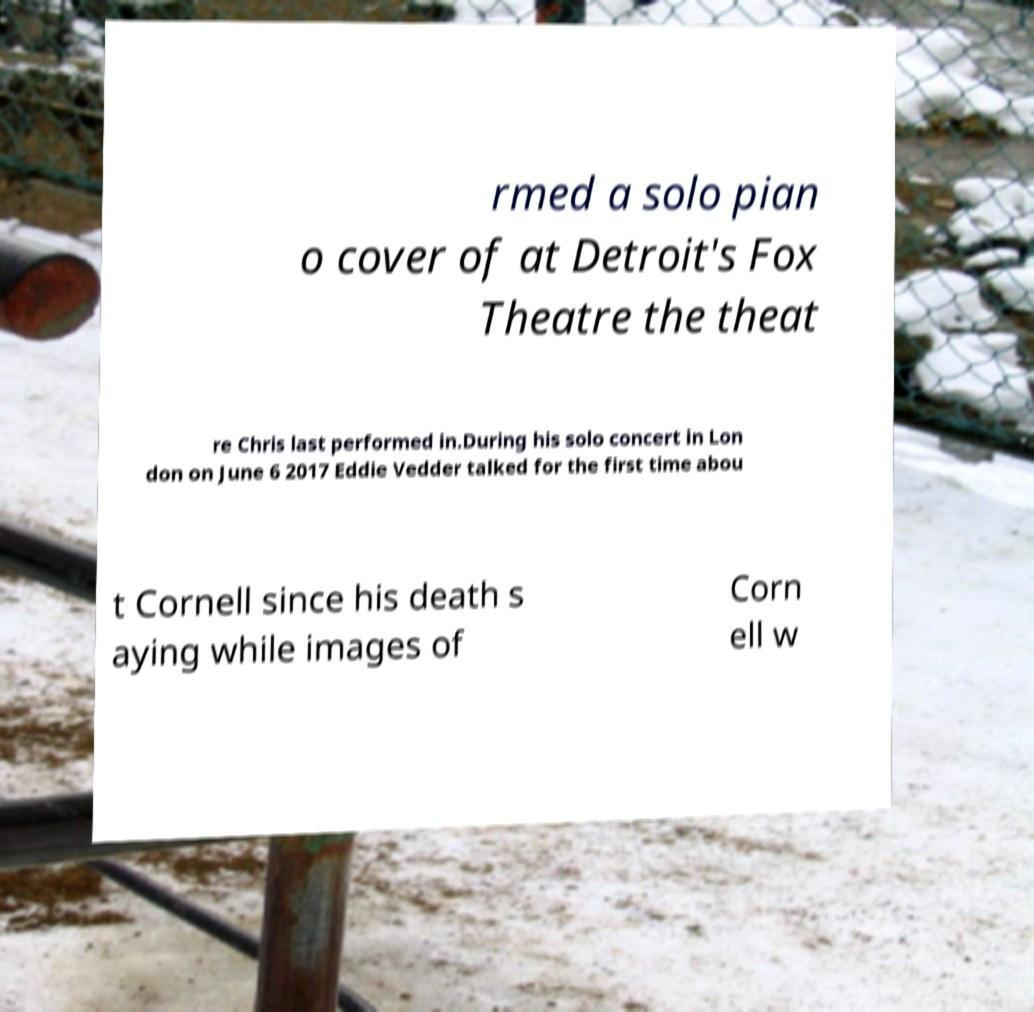I need the written content from this picture converted into text. Can you do that? rmed a solo pian o cover of at Detroit's Fox Theatre the theat re Chris last performed in.During his solo concert in Lon don on June 6 2017 Eddie Vedder talked for the first time abou t Cornell since his death s aying while images of Corn ell w 